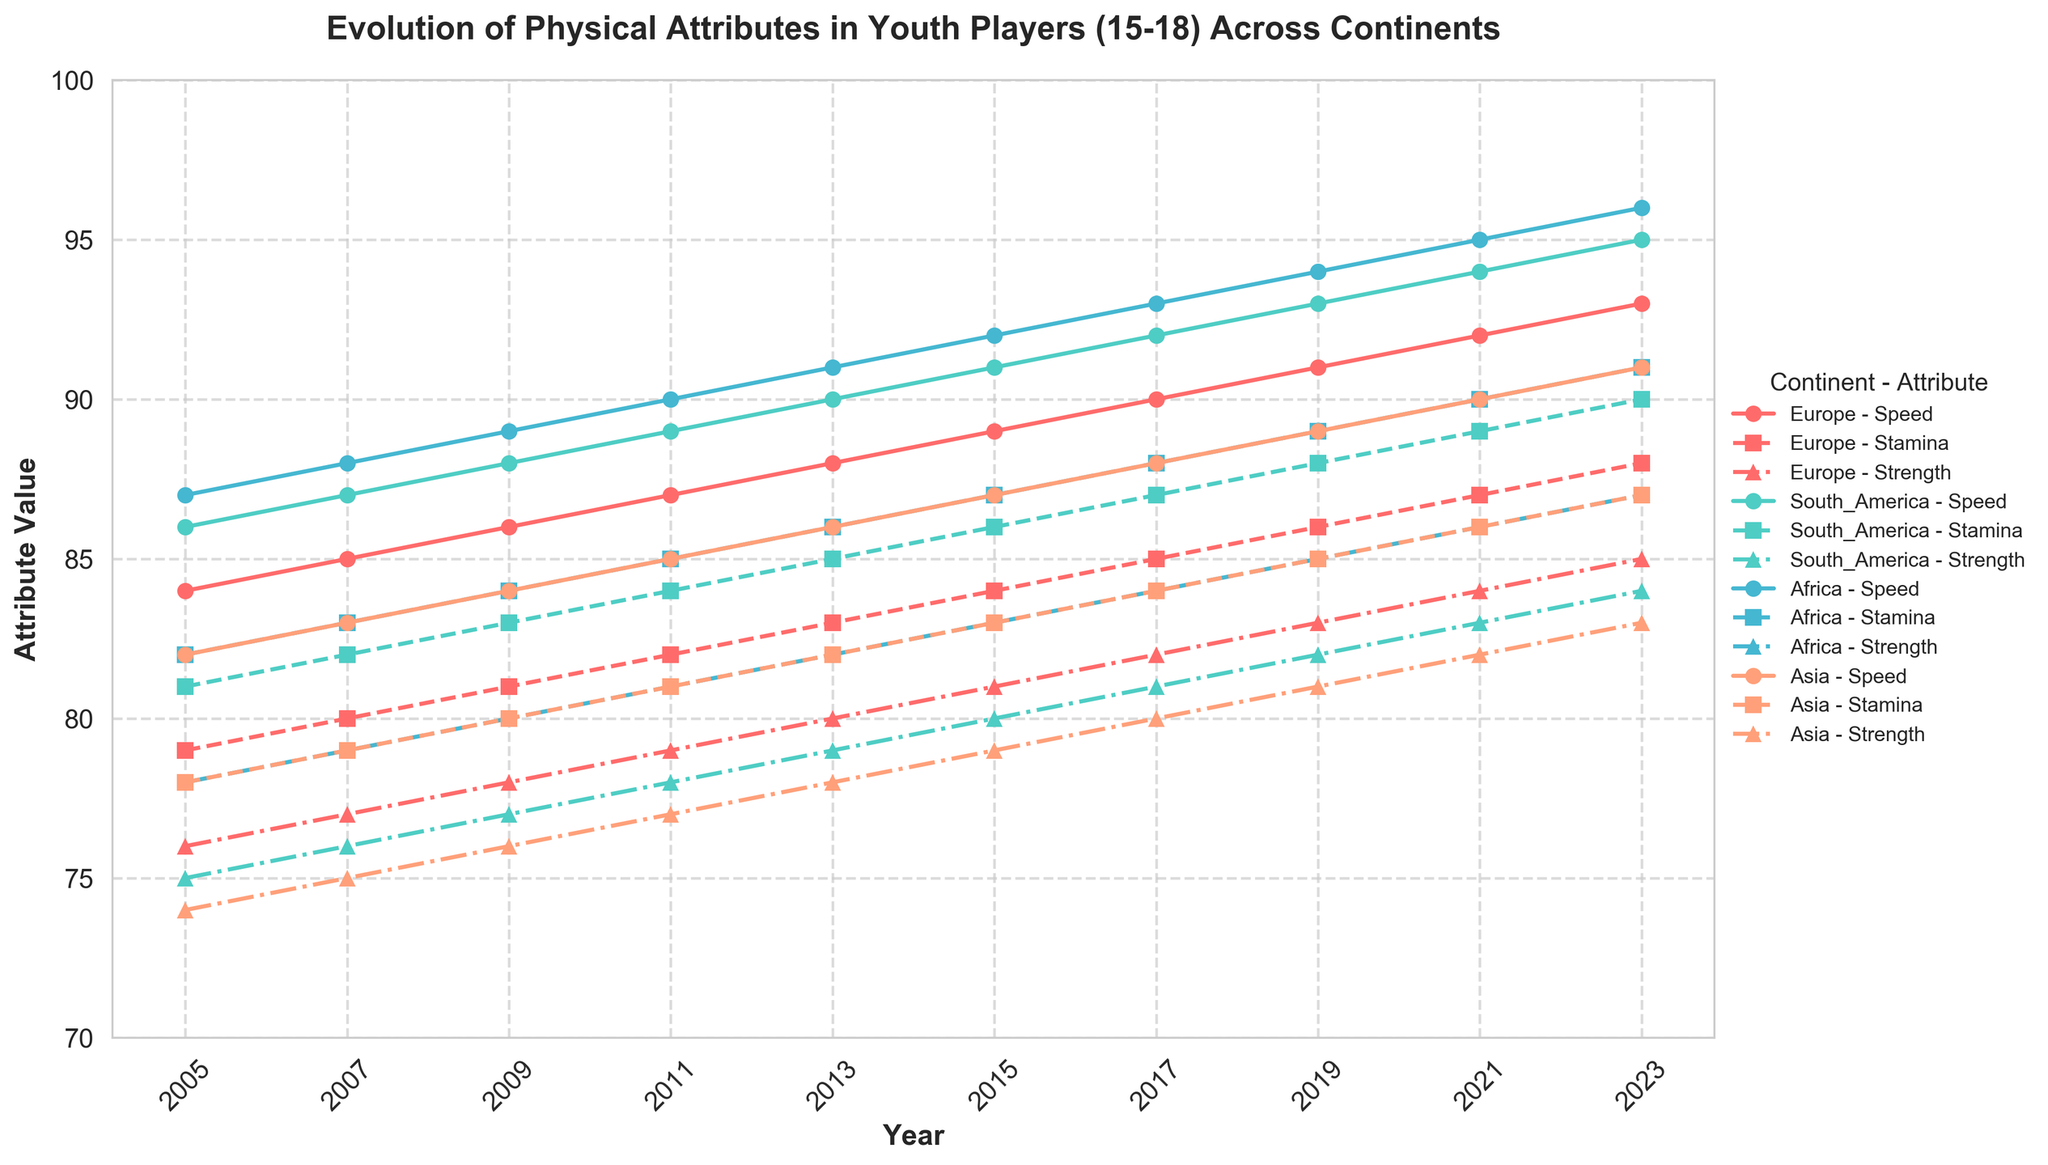What is the trend of speed attributes in African youth players from 2005 to 2023? The trend of speed attributes in African youth players can be derived by looking at the line representing Africa's speed. In 2005, the attribute value is 87, and it increases consistently each year until it reaches 96 in 2023.
Answer: Increasing trend Which continent showed the highest improvement in stamina from 2005 to 2023? To find the highest improvement, calculate the difference in stamina values for each continent between 2005 and 2023. Europe: 88 - 79 = 9, South America: 90 - 81 = 9, Africa: 91 - 82 = 9, Asia: 87 - 78 = 9. All continents showed the same improvement.
Answer: All continents By how much did the strength attribute improve in South America from 2005 to 2023? The strength attribute in South America in 2005 was 75 and improved to 84 in 2023, so the improvement is 84 - 75 = 9.
Answer: 9 Which continent had the highest speed attribute in 2023? The highest speed attribute in 2023 can be determined by comparing the speed values across continents. Europe: 93, South America: 95, Africa: 96, Asia: 91. Therefore, Africa had the highest speed attribute in 2023.
Answer: Africa In which year did the stamina attribute in Asian youth players surpass that of European youth players? Compare the stamina values of Asia and Europe year by year. In 2005: Asia 78, Europe 79; 2007: Asia 79, Europe 80; 2009: Asia 80, Europe 81; 2011: Asia 81, Europe 82; 2013: Asia 82, Europe 83; 2015: Asia 83, Europe 84; 2017: Asia 84, Europe 85; 2019: Asia 85, Europe 86; 2021: Asia 86, Europe 87; 2023: Asia 87, Europe 88. Therefore, the stamina attribute in Asian youth players never surpassed that of European youth players.
Answer: Never What was the average strength attribute in 2023 across all continents? Calculate the average by summing the strength attributes of all continents in 2023 and dividing by the number of continents. (85 + 84 + 87 + 83) / 4 = 339 / 4 = 84.75.
Answer: 84.75 Which year saw the highest increase in speed attributes for European youth players compared to the previous year? Calculate the year-over-year increase for each year and identify the highest one. 2007: 85 - 84 = 1, 2009: 86 - 85 = 1, 2011: 87 - 86 = 1, 2013: 88 - 87 = 1, 2015: 89 - 88 = 1, 2017: 90 - 89 = 1, 2019: 91 - 90 = 1, 2021: 92 - 91 = 1, 2023: 93 - 92 = 1. The increases are the same every year.
Answer: No specific year Which visual attribute helps in distinguishing the strength attribute for Africa in the plot? The strength attribute for Africa can be distinguished by its unique marker and line style, which is represented by a red line combined with a triangle-up marker.
Answer: Red line and triangle-up marker 